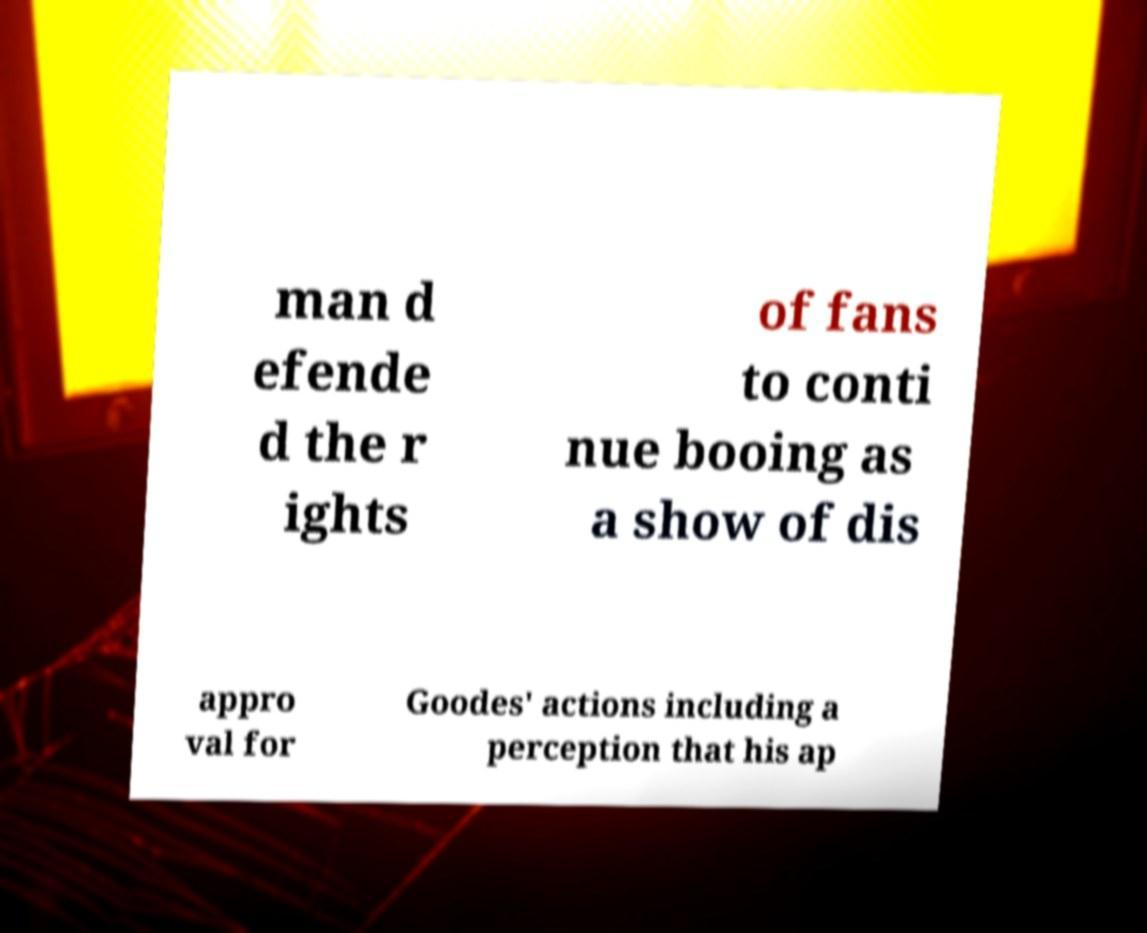Can you accurately transcribe the text from the provided image for me? man d efende d the r ights of fans to conti nue booing as a show of dis appro val for Goodes' actions including a perception that his ap 